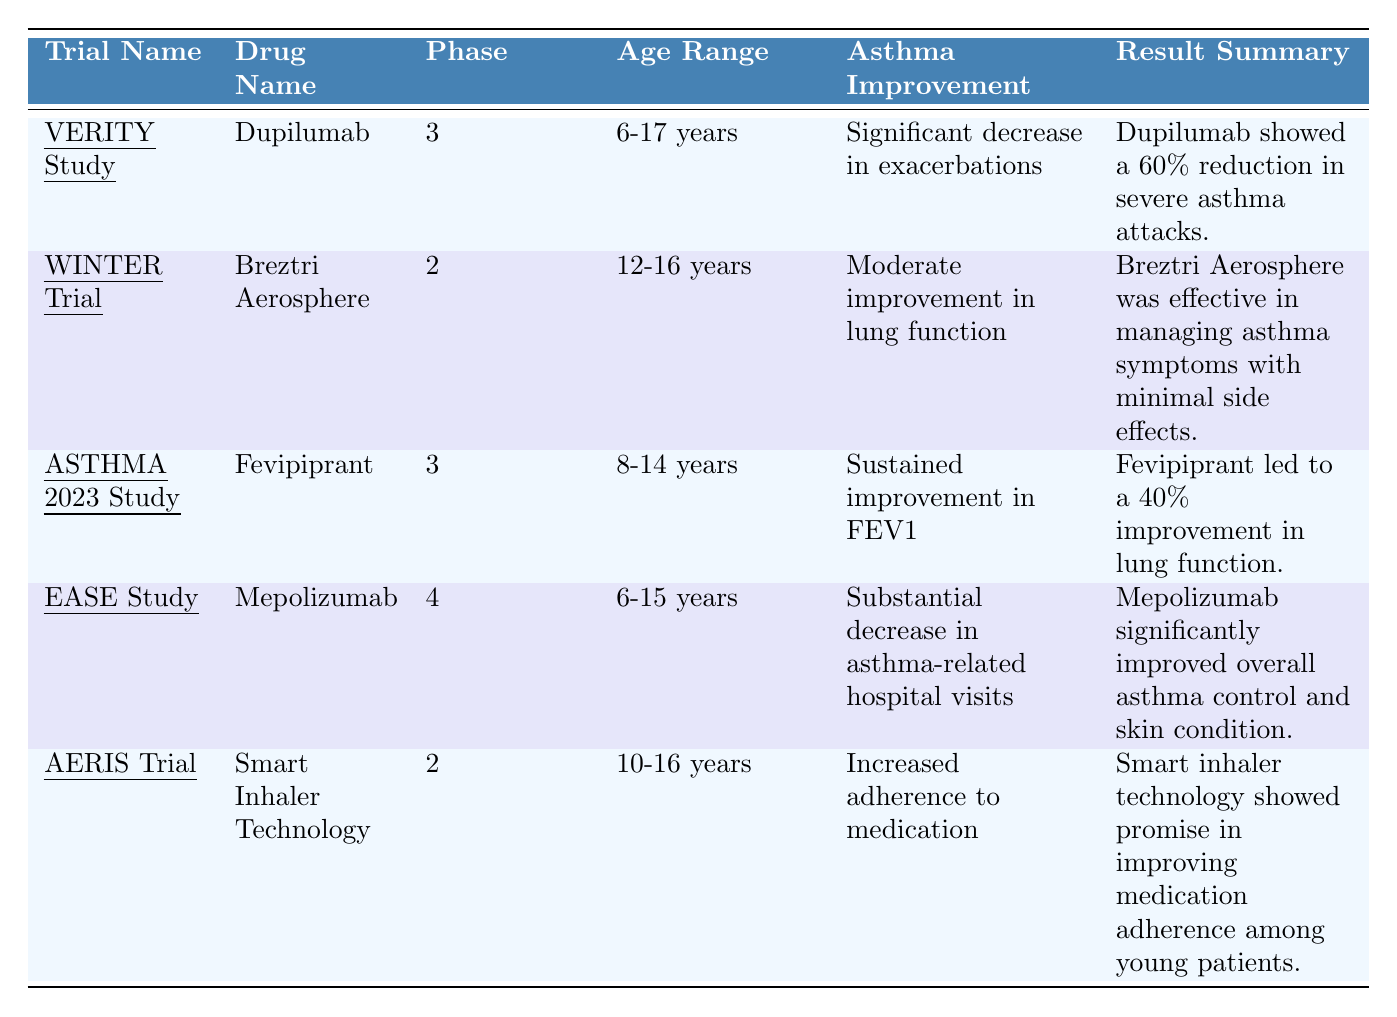What is the drug tested in the WINTER Trial? The table lists "Breztri Aerosphere" in the row for the WINTER Trial.
Answer: Breztri Aerosphere Which trial had the longest duration? The EASE Study has a duration of 36 weeks, which is longer than the other trials listed.
Answer: EASE Study Is there any trial that improved both asthma and eczema? The EASE Study improved both asthma control and had a moderate reduction in eczema symptoms as seen in the table.
Answer: Yes How many trials are in phase 3? There are two trials in phase 3: the VERITY Study and the ASTHMA 2023 Study.
Answer: 2 Which drug showed the highest percentage reduction in severe asthma attacks? The VERITY Study with Dupilumab showed a 60% reduction in severe asthma attacks, which is the highest listed.
Answer: Dupilumab Did the AERIS Trial report any effects on eczema? The AERIS Trial reported "no measurable effects on eczema" according to the table.
Answer: No What are the age ranges for the trials using Dupilumab and Mepolizumab? The VERITY Study using Dupilumab has an age range of 6-17 years, and the EASE Study using Mepolizumab has an age range of 6-15 years.
Answer: 6-17 years and 6-15 years Which trial had a moderate effect on eczema without significant asthma improvement? The WINTER Trial reported "no significant effects on eczema" and had a moderate improvement in lung function.
Answer: WINTER Trial How much improvement in lung function did Fevipiprant show? The ASTHMA 2023 Study reports a 40% improvement in lung function with Fevipiprant.
Answer: 40% What is the relationship between asthma improvement and eczema improvement in the EASE Study? The EASE Study shows significant asthma improvement with a moderate reduction in eczema symptoms, indicating a positive relationship.
Answer: Positive relationship Did any trials report adverse effects on eczema? Only the ASTHMA 2023 Study noted "participants reported no adverse effects on eczema," while others either noted improvement or no significant effects.
Answer: No 